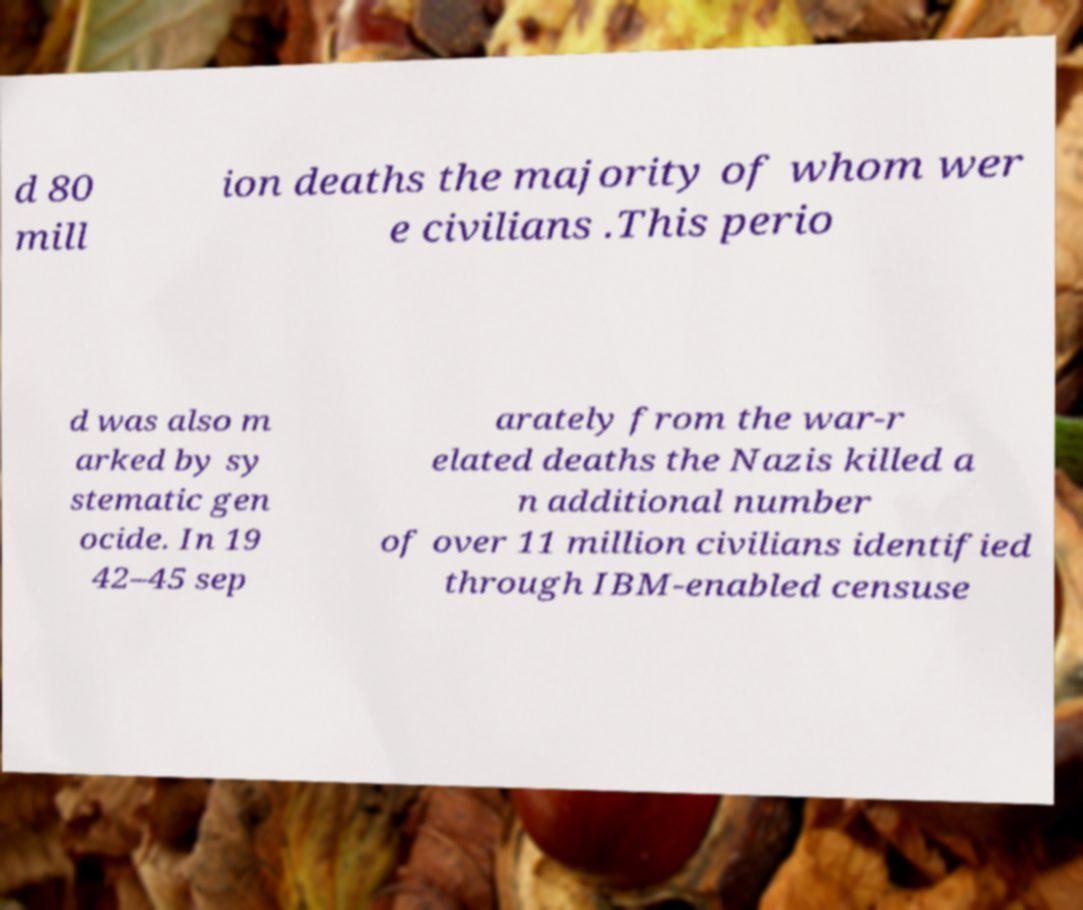Could you assist in decoding the text presented in this image and type it out clearly? d 80 mill ion deaths the majority of whom wer e civilians .This perio d was also m arked by sy stematic gen ocide. In 19 42–45 sep arately from the war-r elated deaths the Nazis killed a n additional number of over 11 million civilians identified through IBM-enabled censuse 